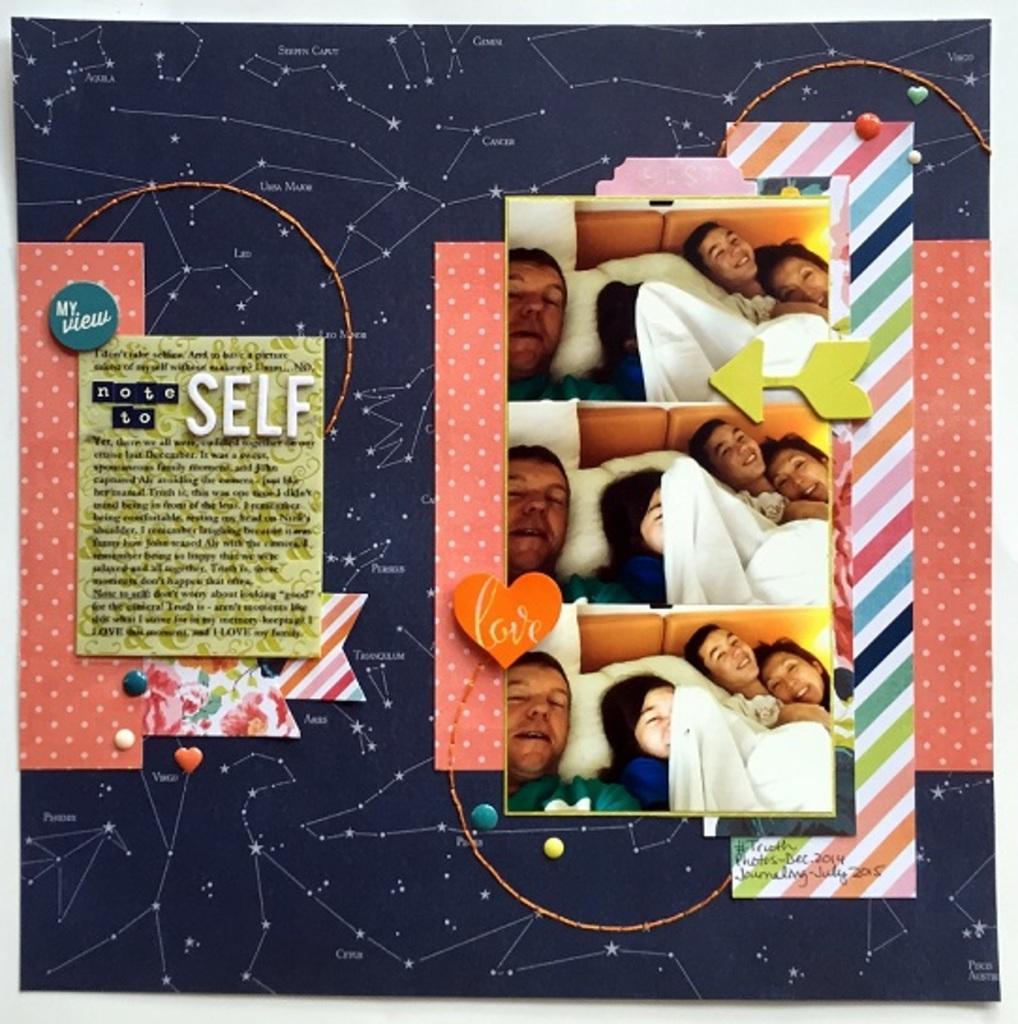Can you describe this image briefly? In this picture we can see few posts on the notice board. 